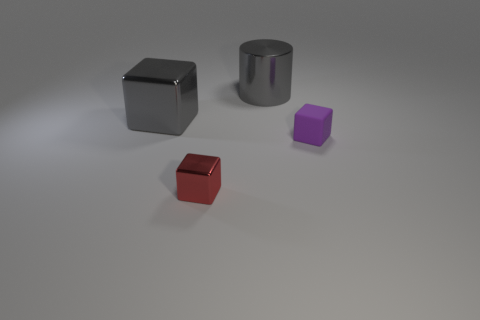Subtract 1 blocks. How many blocks are left? 2 Add 4 big cubes. How many objects exist? 8 Subtract all cylinders. How many objects are left? 3 Subtract 0 cyan cylinders. How many objects are left? 4 Subtract all gray metal cubes. Subtract all small shiny things. How many objects are left? 2 Add 1 small purple things. How many small purple things are left? 2 Add 1 large brown matte things. How many large brown matte things exist? 1 